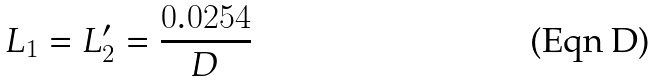Convert formula to latex. <formula><loc_0><loc_0><loc_500><loc_500>L _ { 1 } = L _ { 2 } ^ { \prime } = \frac { 0 . 0 2 5 4 } { D }</formula> 